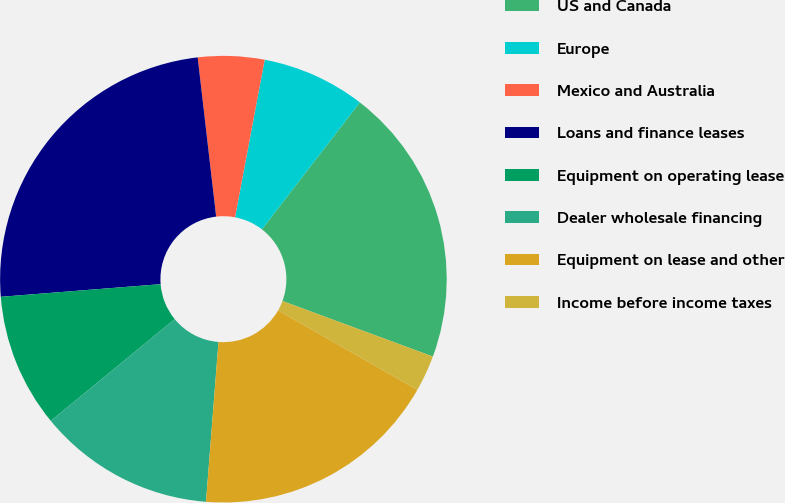Convert chart. <chart><loc_0><loc_0><loc_500><loc_500><pie_chart><fcel>US and Canada<fcel>Europe<fcel>Mexico and Australia<fcel>Loans and finance leases<fcel>Equipment on operating lease<fcel>Dealer wholesale financing<fcel>Equipment on lease and other<fcel>Income before income taxes<nl><fcel>20.17%<fcel>7.5%<fcel>4.8%<fcel>24.42%<fcel>9.68%<fcel>12.82%<fcel>17.99%<fcel>2.62%<nl></chart> 